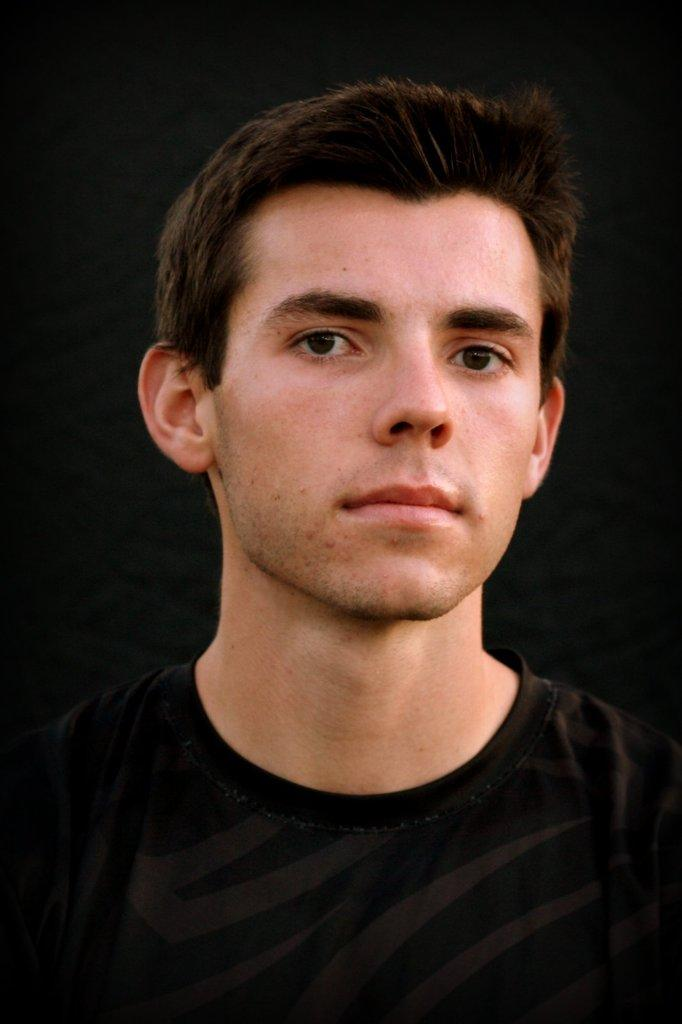What is the main subject in the image? There is a man in the image. What type of home does the man live in, as seen in the image? The image does not provide any information about the man's home. 